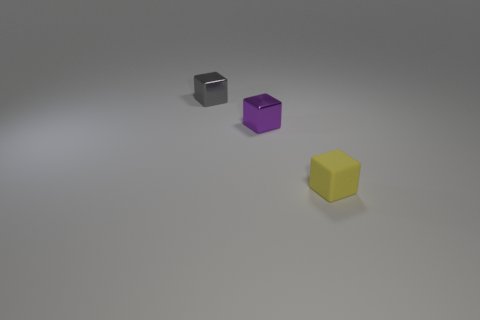What do the different surfaces of the objects tell us about the lighting in the scene? The reflective surface of the black cube and the shiny finish of the purple cube suggest that there is a strong light source in the scene, which is evident from the highlights and reflections on these surfaces. The matte surface of the yellow cube diffuses light differently, indicating the source of light is more diffused or ambient. 